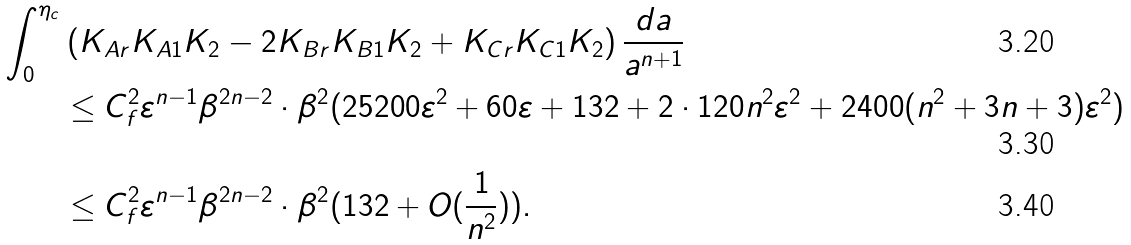Convert formula to latex. <formula><loc_0><loc_0><loc_500><loc_500>\int _ { 0 } ^ { \eta _ { c } } & \left ( K _ { A r } K _ { A 1 } K _ { 2 } - 2 K _ { B r } K _ { B 1 } K _ { 2 } + K _ { C r } K _ { C 1 } K _ { 2 } \right ) \frac { d a } { a ^ { n + 1 } } \\ & \leq C _ { f } ^ { 2 } \varepsilon ^ { n - 1 } \beta ^ { 2 n - 2 } \cdot \beta ^ { 2 } ( 2 5 2 0 0 \varepsilon ^ { 2 } + 6 0 \varepsilon + 1 3 2 + 2 \cdot 1 2 0 n ^ { 2 } \varepsilon ^ { 2 } + 2 4 0 0 ( n ^ { 2 } + 3 n + 3 ) \varepsilon ^ { 2 } ) \\ & \leq C _ { f } ^ { 2 } \varepsilon ^ { n - 1 } \beta ^ { 2 n - 2 } \cdot \beta ^ { 2 } ( 1 3 2 + O ( \frac { 1 } { n ^ { 2 } } ) ) .</formula> 